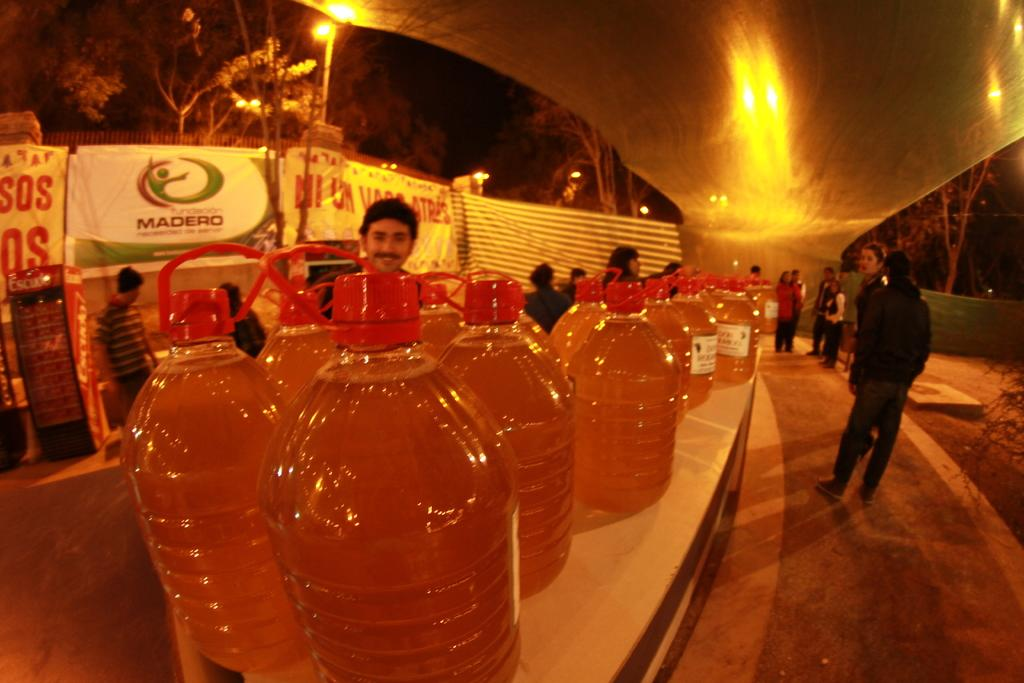<image>
Provide a brief description of the given image. A sign for Madero sits near a huge row of bottles of brown liquid. 